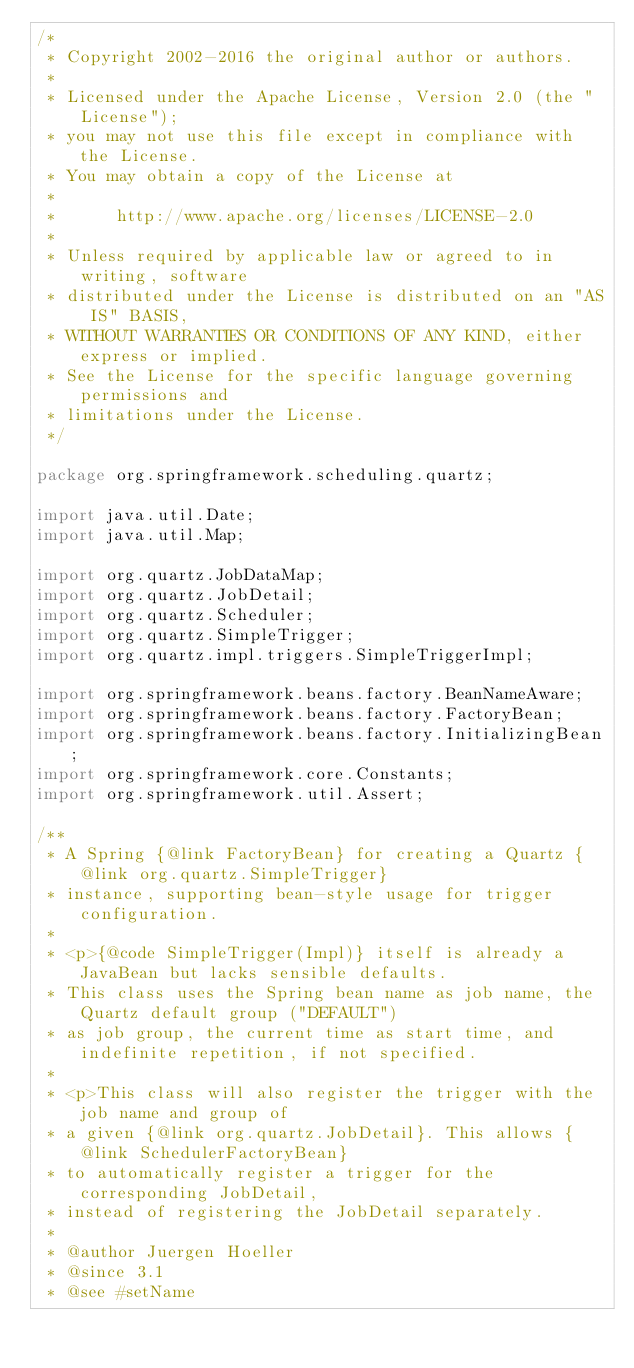<code> <loc_0><loc_0><loc_500><loc_500><_Java_>/*
 * Copyright 2002-2016 the original author or authors.
 *
 * Licensed under the Apache License, Version 2.0 (the "License");
 * you may not use this file except in compliance with the License.
 * You may obtain a copy of the License at
 *
 *      http://www.apache.org/licenses/LICENSE-2.0
 *
 * Unless required by applicable law or agreed to in writing, software
 * distributed under the License is distributed on an "AS IS" BASIS,
 * WITHOUT WARRANTIES OR CONDITIONS OF ANY KIND, either express or implied.
 * See the License for the specific language governing permissions and
 * limitations under the License.
 */

package org.springframework.scheduling.quartz;

import java.util.Date;
import java.util.Map;

import org.quartz.JobDataMap;
import org.quartz.JobDetail;
import org.quartz.Scheduler;
import org.quartz.SimpleTrigger;
import org.quartz.impl.triggers.SimpleTriggerImpl;

import org.springframework.beans.factory.BeanNameAware;
import org.springframework.beans.factory.FactoryBean;
import org.springframework.beans.factory.InitializingBean;
import org.springframework.core.Constants;
import org.springframework.util.Assert;

/**
 * A Spring {@link FactoryBean} for creating a Quartz {@link org.quartz.SimpleTrigger}
 * instance, supporting bean-style usage for trigger configuration.
 *
 * <p>{@code SimpleTrigger(Impl)} itself is already a JavaBean but lacks sensible defaults.
 * This class uses the Spring bean name as job name, the Quartz default group ("DEFAULT")
 * as job group, the current time as start time, and indefinite repetition, if not specified.
 *
 * <p>This class will also register the trigger with the job name and group of
 * a given {@link org.quartz.JobDetail}. This allows {@link SchedulerFactoryBean}
 * to automatically register a trigger for the corresponding JobDetail,
 * instead of registering the JobDetail separately.
 *
 * @author Juergen Hoeller
 * @since 3.1
 * @see #setName</code> 